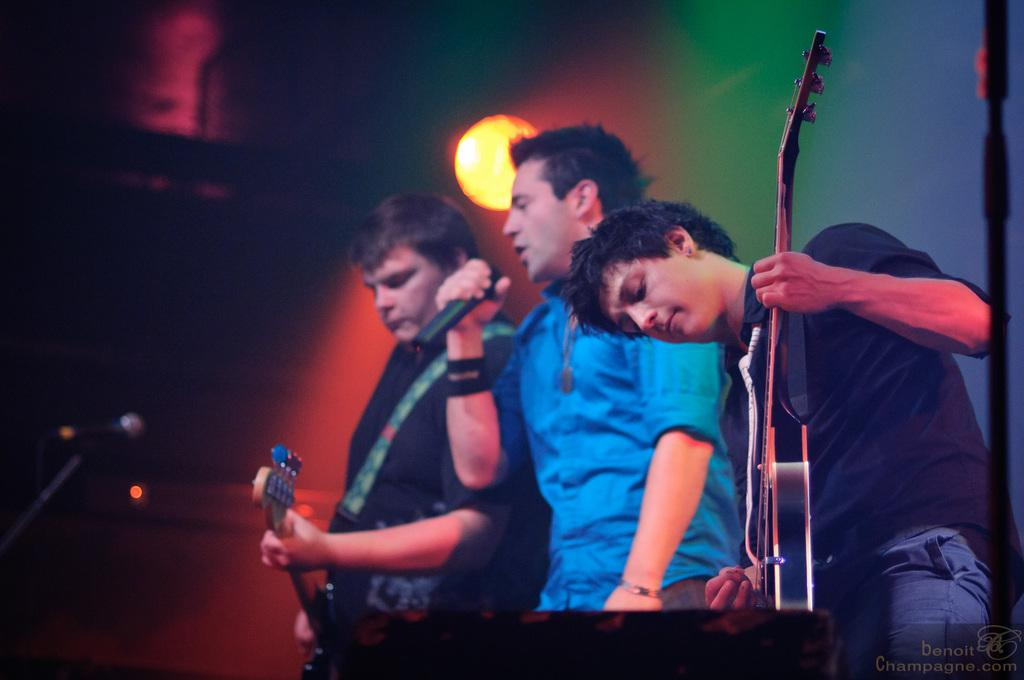What is happening in the image involving the people? Some of the people are holding guitars and playing them. Can you describe the man in the blue shirt? The man in the blue shirt is holding a microphone and singing. What can be seen in the background of the image? There are show lights visible in the background. How many bikes are being ridden by the people in the image? There are no bikes present in the image; the people are playing musical instruments and singing. What type of division is taking place in the image? There is no division taking place in the image; it features people playing music and singing. 